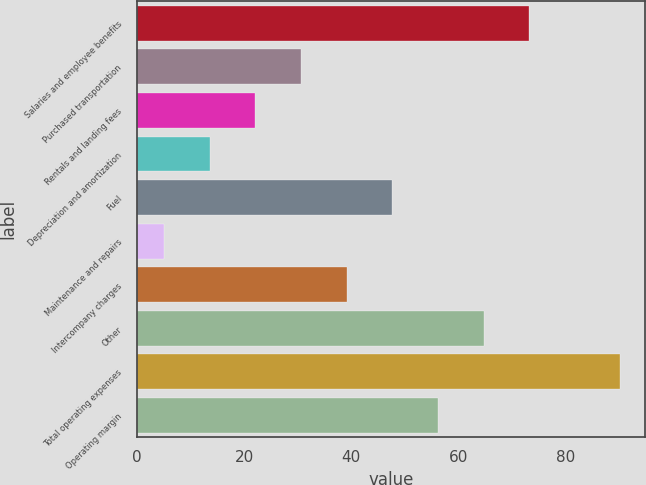Convert chart to OTSL. <chart><loc_0><loc_0><loc_500><loc_500><bar_chart><fcel>Salaries and employee benefits<fcel>Purchased transportation<fcel>Rentals and landing fees<fcel>Depreciation and amortization<fcel>Fuel<fcel>Maintenance and repairs<fcel>Intercompany charges<fcel>Other<fcel>Total operating expenses<fcel>Operating margin<nl><fcel>73.26<fcel>30.66<fcel>22.14<fcel>13.62<fcel>47.7<fcel>5.1<fcel>39.18<fcel>64.74<fcel>90.3<fcel>56.22<nl></chart> 